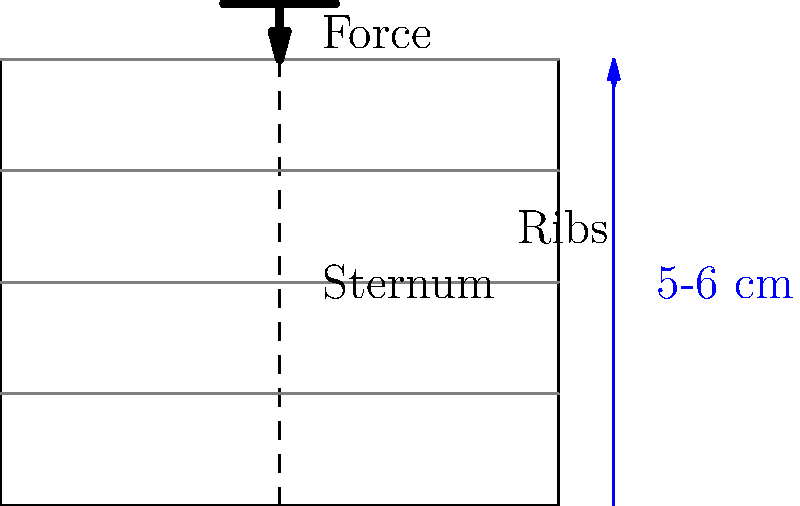During CPR, what is the recommended depth of chest compressions for an adult patient, and how does this relate to the biomechanics of the thoracic cavity? To understand the biomechanics of chest compressions during CPR, let's break it down step-by-step:

1. Chest Anatomy: The thoracic cavity is protected by the ribcage and sternum. The sternum acts as a lever during compressions.

2. Compression Depth: The American Heart Association recommends a compression depth of 5-6 cm (2-2.4 inches) for adults. This depth is crucial for effective CPR.

3. Force Application: The rescuer applies force to the lower half of the sternum. This force is transmitted through the sternum to the heart and great vessels.

4. Thoracic Pump Mechanism: As the chest is compressed:
   a) The heart is squeezed between the sternum and the spine.
   b) Intrathoracic pressure increases, forcing blood out of the heart and into the circulation.

5. Recoil: After each compression, it's crucial to allow full chest recoil. This creates negative intrathoracic pressure, which helps venous return and cardiac filling.

6. Compression Rate: Compressions should be performed at a rate of 100-120 per minute to maintain adequate circulation.

7. Biomechanical Efficiency: The 5-6 cm depth optimizes the balance between:
   a) Generating sufficient cardiac output
   b) Minimizing the risk of rib fractures or internal organ damage

8. Energy Transfer: The sternum's lever-like action helps distribute the force across the ribcage, reducing the risk of localized trauma.

By adhering to the recommended depth, rate, and allowing full recoil, the biomechanics of chest compressions effectively simulate the heart's pumping action, maintaining critical organ perfusion during cardiac arrest.
Answer: 5-6 cm depth, optimizing cardiac output while minimizing injury risk. 